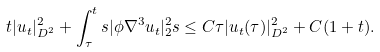<formula> <loc_0><loc_0><loc_500><loc_500>& t | u _ { t } | ^ { 2 } _ { D ^ { 2 } } + \int _ { \tau } ^ { t } s | \phi \nabla ^ { 3 } u _ { t } | ^ { 2 } _ { 2 } s \leq C \tau | u _ { t } ( \tau ) | ^ { 2 } _ { D ^ { 2 } } + C ( 1 + t ) .</formula> 